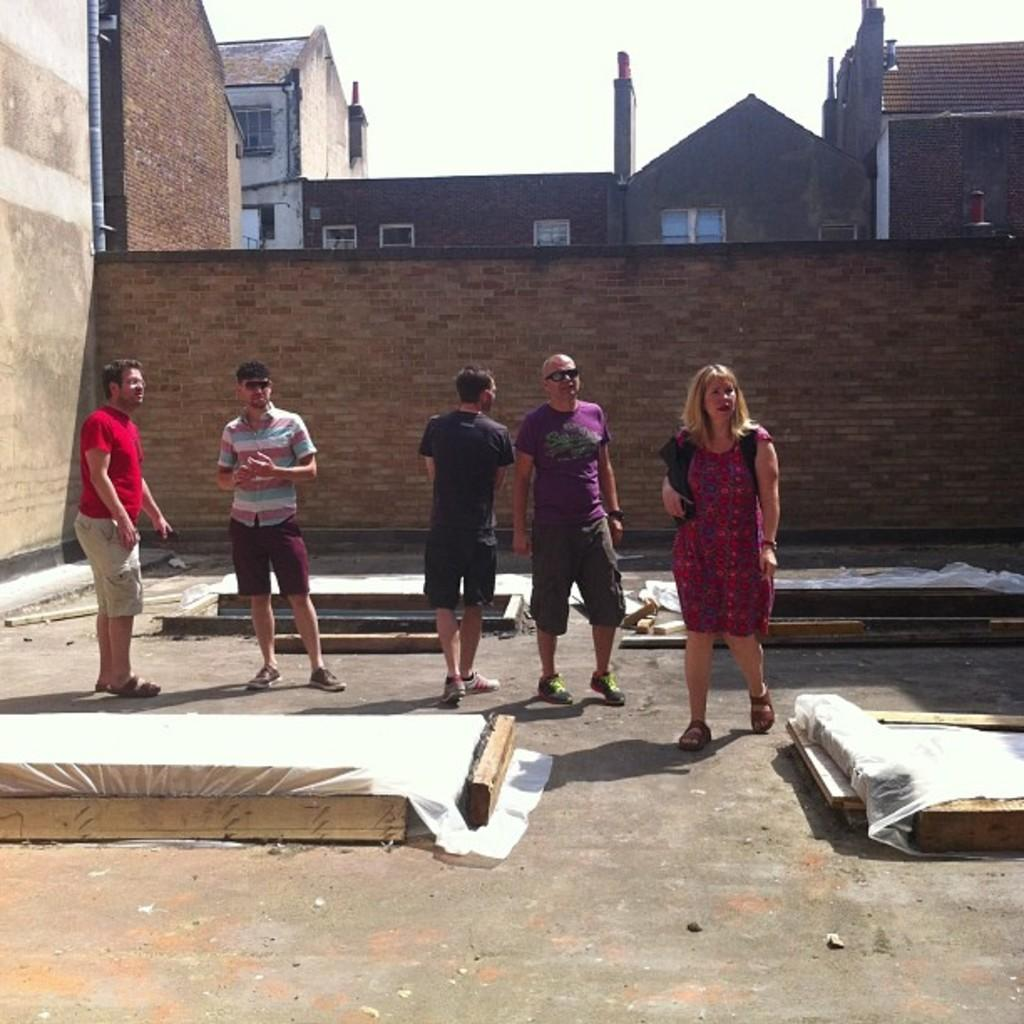What type of material is used for the planks in the image? The wooden planks in the image are made of wood. What else can be seen on the floor in the image? There are cover sheets on the floor in the image. How many people are on the floor in the image? Five people are on the floor in the image. What is visible in the background of the image? There is a wall, buildings with windows, and the sky visible in the background of the image. Where is the faucet located in the image? There is no faucet present in the image. What type of apple is being used as a prop in the image? There is no apple present in the image. 